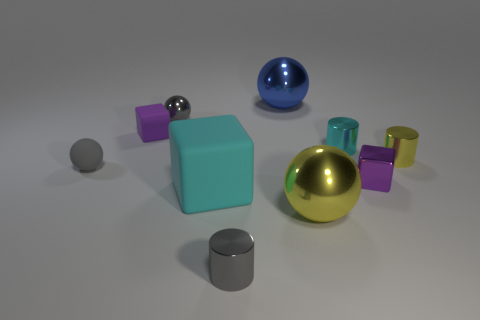Subtract all small purple cubes. How many cubes are left? 1 Subtract 2 spheres. How many spheres are left? 2 Subtract all yellow balls. How many balls are left? 3 Subtract all balls. How many objects are left? 6 Subtract all blue cylinders. Subtract all brown blocks. How many cylinders are left? 3 Subtract 0 brown cylinders. How many objects are left? 10 Subtract all red cylinders. How many purple cubes are left? 2 Subtract all tiny yellow matte spheres. Subtract all yellow metallic cylinders. How many objects are left? 9 Add 5 metal cylinders. How many metal cylinders are left? 8 Add 5 large blue metal objects. How many large blue metal objects exist? 6 